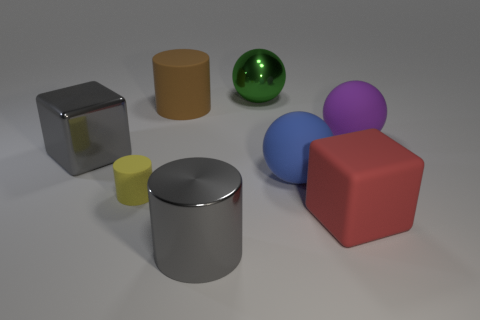Add 1 blue things. How many objects exist? 9 Subtract all spheres. How many objects are left? 5 Add 7 tiny cyan cylinders. How many tiny cyan cylinders exist? 7 Subtract 0 brown blocks. How many objects are left? 8 Subtract all big cyan rubber spheres. Subtract all red matte objects. How many objects are left? 7 Add 6 big brown cylinders. How many big brown cylinders are left? 7 